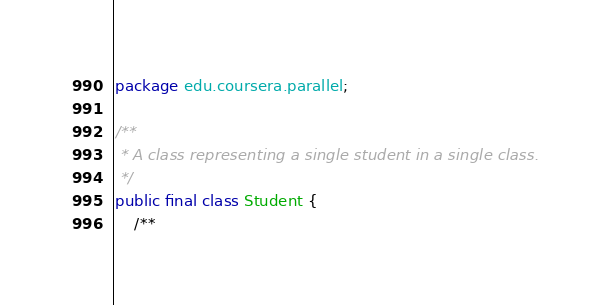Convert code to text. <code><loc_0><loc_0><loc_500><loc_500><_Java_>package edu.coursera.parallel;

/**
 * A class representing a single student in a single class.
 */
public final class Student {
    /**</code> 